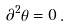Convert formula to latex. <formula><loc_0><loc_0><loc_500><loc_500>\partial ^ { 2 } \theta = 0 \, .</formula> 